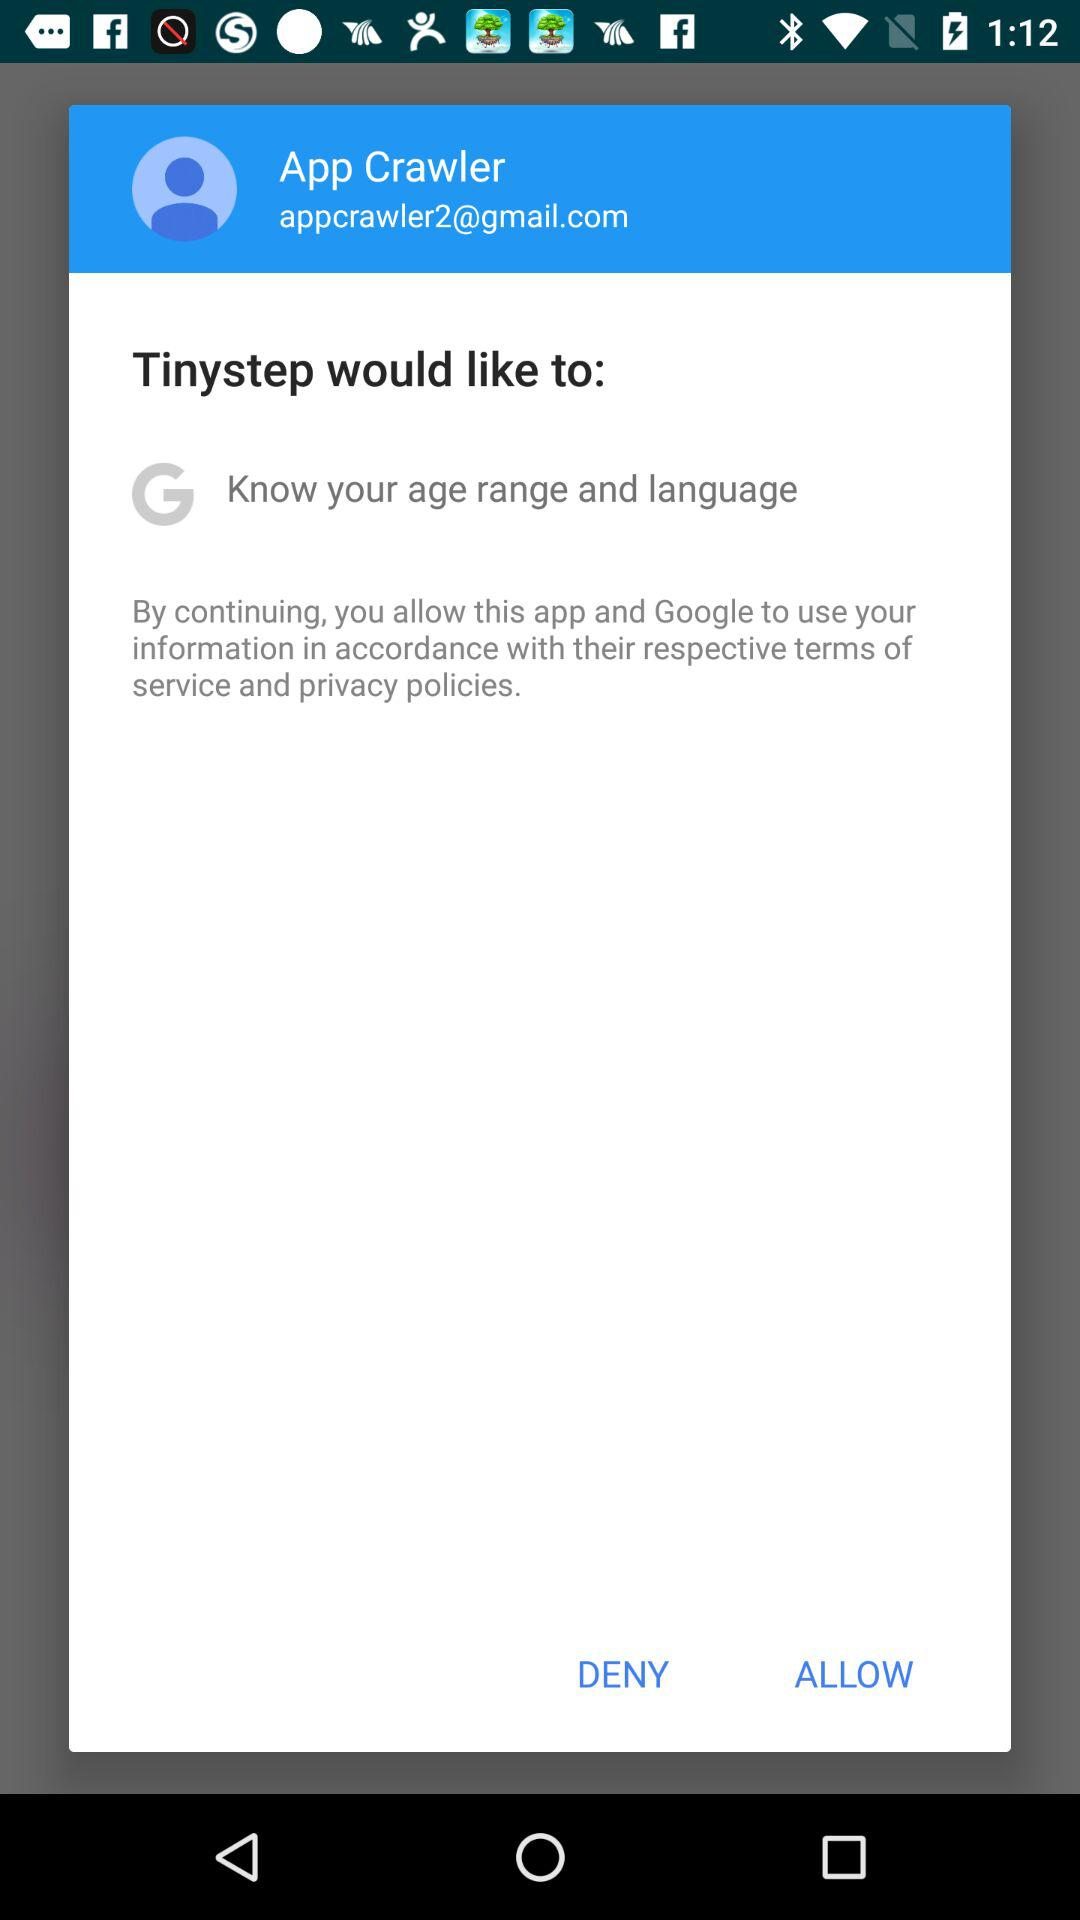What is the user name? The user name is App Crawler. 